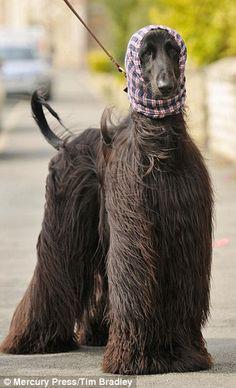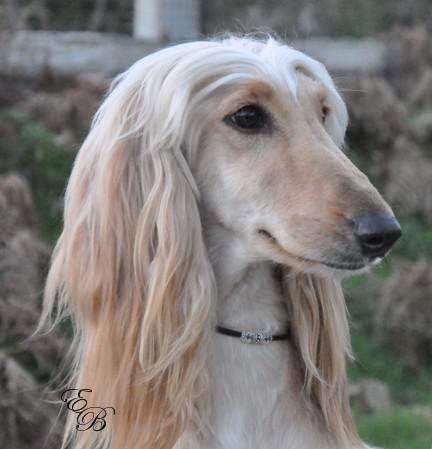The first image is the image on the left, the second image is the image on the right. Analyze the images presented: Is the assertion "There is an Afghan dog being held on a leash." valid? Answer yes or no. Yes. The first image is the image on the left, the second image is the image on the right. Considering the images on both sides, is "One image shows a light-colored afghan hound gazing rightward into the distance." valid? Answer yes or no. Yes. 